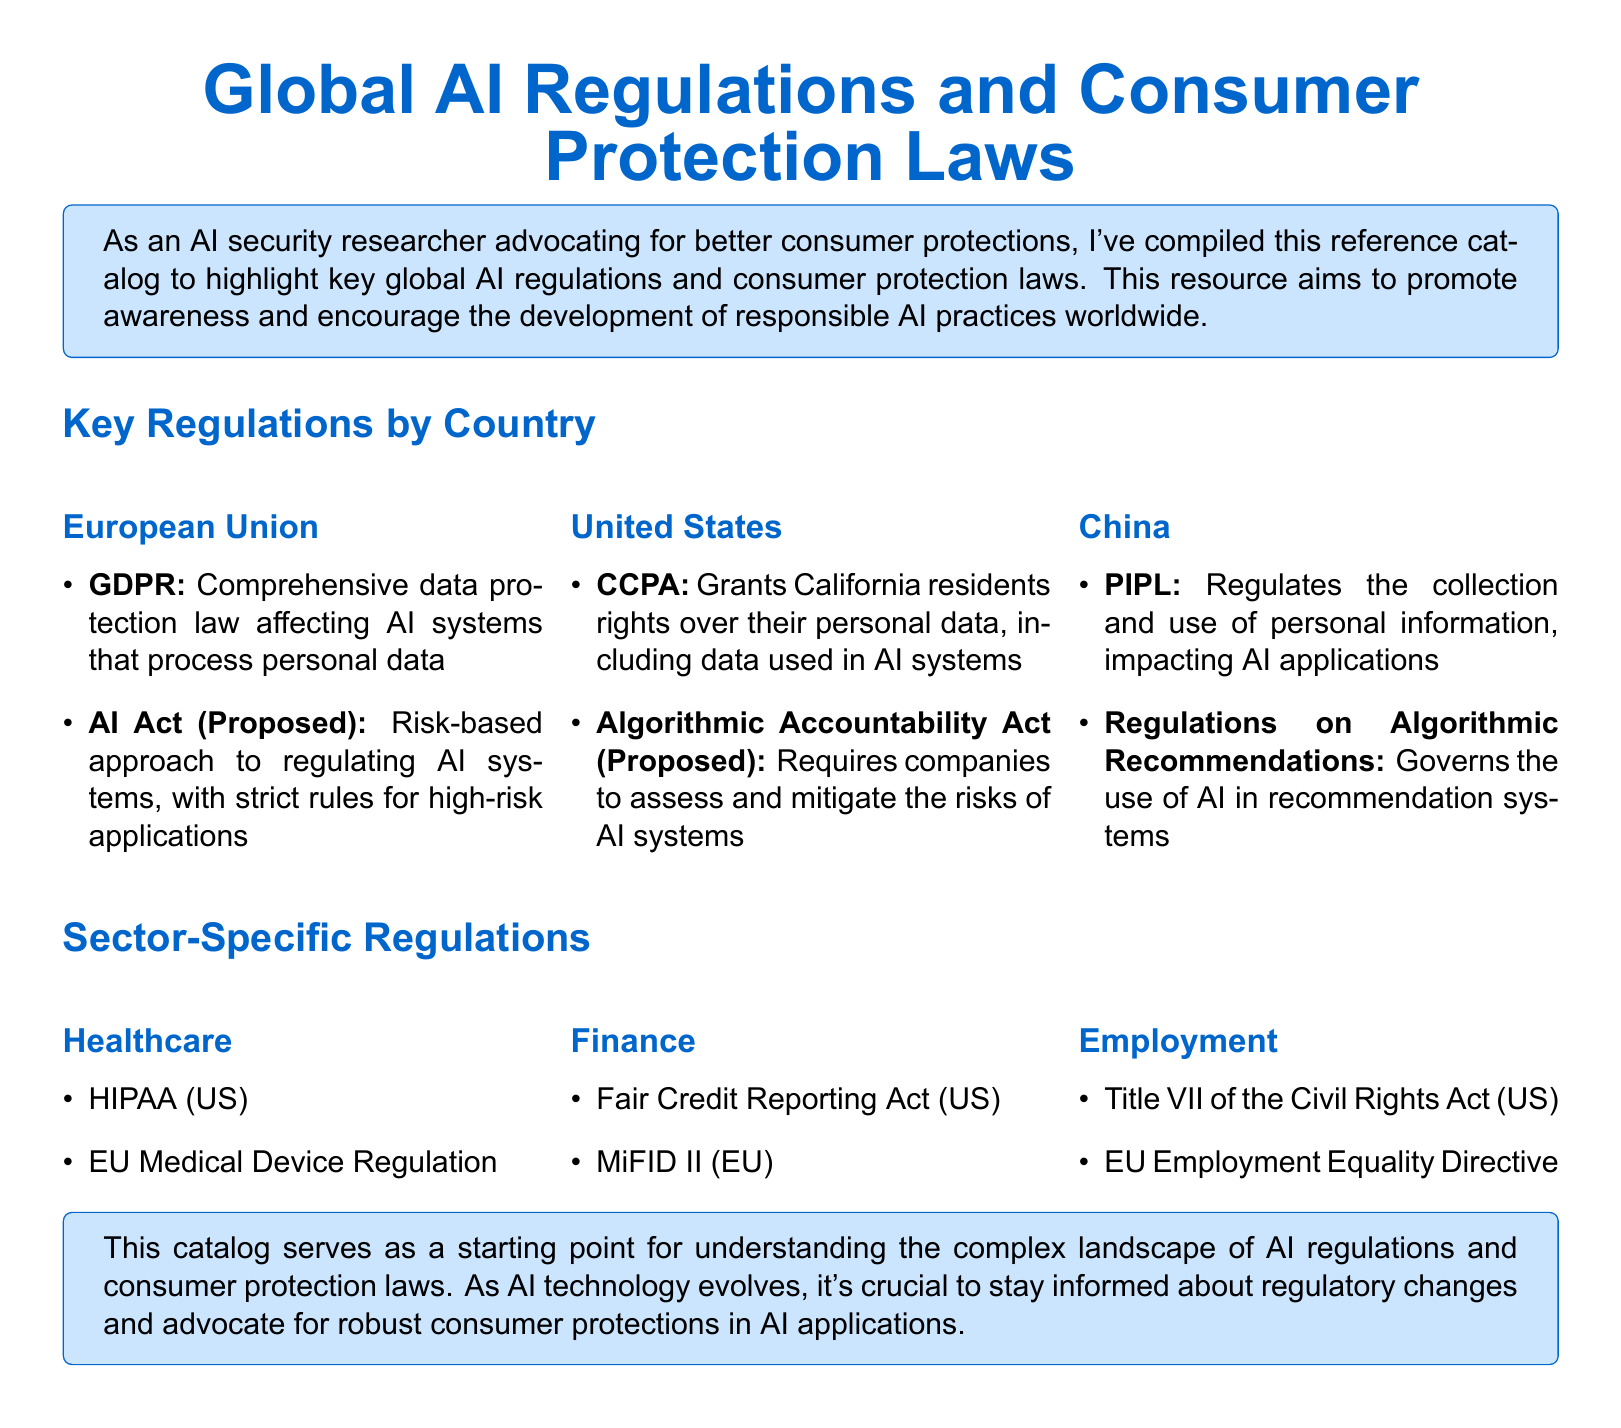What is the main purpose of this catalog? The catalog aims to promote awareness and encourage the development of responsible AI practices worldwide.
Answer: Promote awareness What regulation affects AI systems in the European Union? The GDPR is a comprehensive data protection law that affects AI systems processing personal data.
Answer: GDPR Which proposed regulation in the United States addresses the risks of AI systems? The Algorithmic Accountability Act requires companies to assess and mitigate the risks associated with AI systems.
Answer: Algorithmic Accountability Act What percentage of sectors does the document cover in sector-specific regulations? The document includes three sectors: Healthcare, Finance, and Employment.
Answer: Three sectors What is one regulation listed under the Healthcare sector in the United States? HIPAA is mentioned as a regulation that applies to the Healthcare sector in the US.
Answer: HIPAA What is the regulation that governs AI in recommendation systems in China? The Regulations on Algorithmic Recommendations governs the use of AI in recommendation systems.
Answer: Regulations on Algorithmic Recommendations What directive relates to employment equality in the European Union? The EU Employment Equality Directive is the specific directive regarding employment equality.
Answer: EU Employment Equality Directive What is the proposed regulation in the EU mentioned in the catalog? The AI Act (Proposed) is mentioned as a proposed regulation in the European Union.
Answer: AI Act (Proposed) What does PIPL stand for in China? PIPL stands for the Personal Information Protection Law, which regulates personal data.
Answer: Personal Information Protection Law 